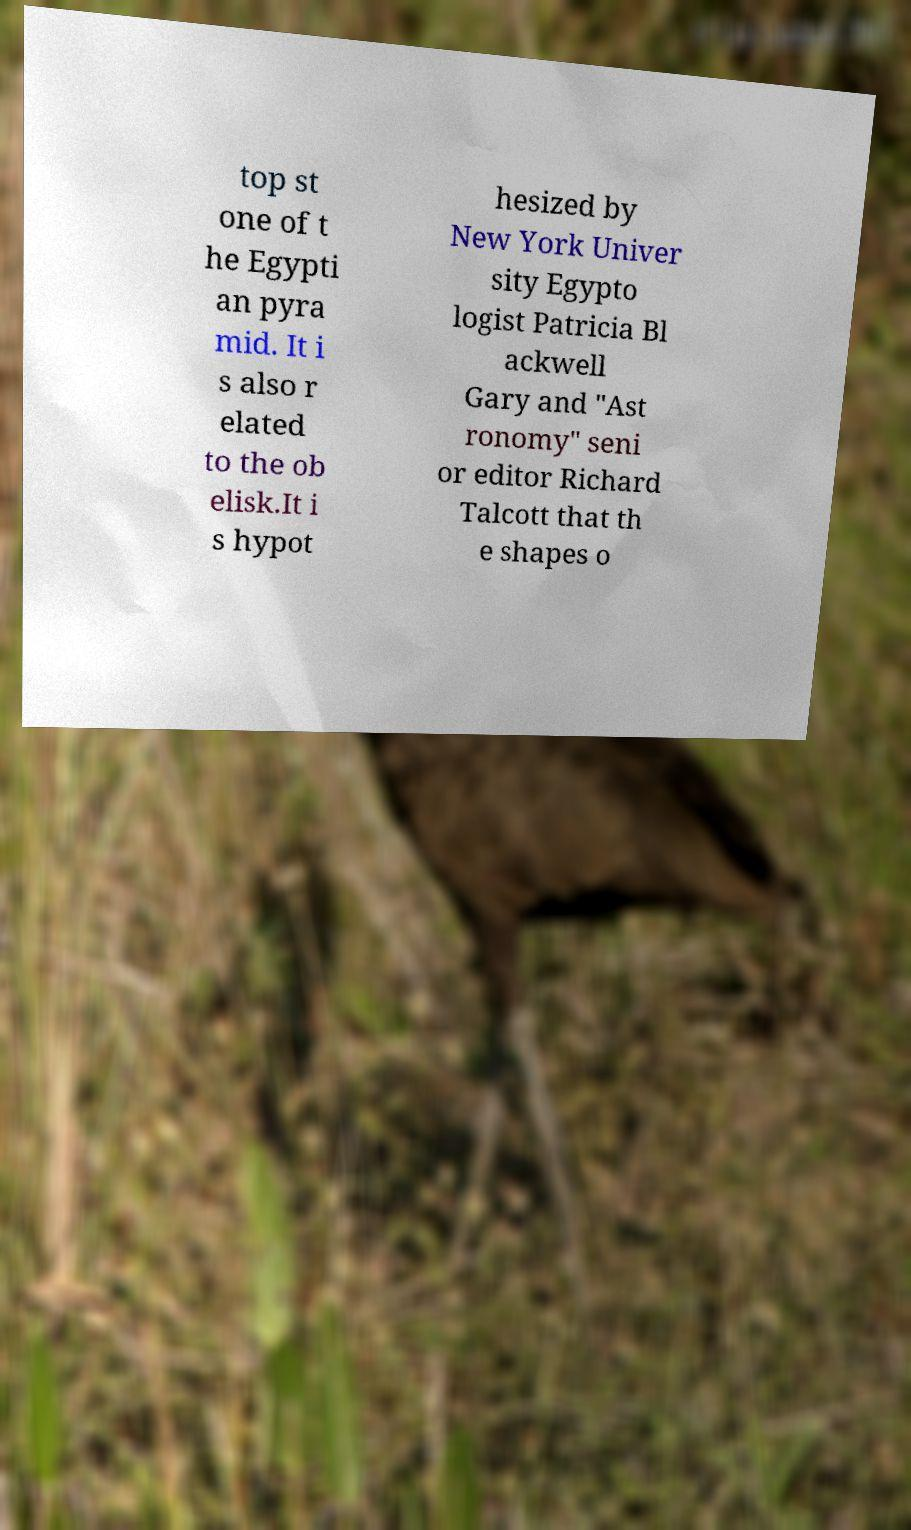I need the written content from this picture converted into text. Can you do that? top st one of t he Egypti an pyra mid. It i s also r elated to the ob elisk.It i s hypot hesized by New York Univer sity Egypto logist Patricia Bl ackwell Gary and "Ast ronomy" seni or editor Richard Talcott that th e shapes o 